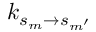<formula> <loc_0><loc_0><loc_500><loc_500>k _ { s _ { m } \rightarrow s _ { m ^ { \prime } } }</formula> 